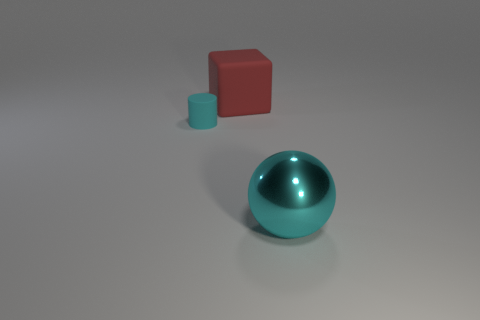What size is the metallic thing that is the same color as the small cylinder?
Ensure brevity in your answer.  Large. Does the large object that is in front of the block have the same material as the big red object?
Offer a very short reply. No. Is there another cylinder of the same color as the small cylinder?
Offer a very short reply. No. Does the cyan object that is behind the large shiny ball have the same shape as the cyan thing that is in front of the tiny cyan rubber cylinder?
Offer a terse response. No. Are there any things made of the same material as the ball?
Give a very brief answer. No. What number of cyan things are tiny rubber objects or matte cubes?
Offer a very short reply. 1. How big is the object that is right of the cyan cylinder and in front of the red block?
Offer a terse response. Large. Is the number of small cyan matte cylinders that are to the left of the tiny cyan cylinder greater than the number of cyan balls?
Make the answer very short. No. What number of balls are green things or large cyan metallic things?
Your response must be concise. 1. There is a thing that is both right of the tiny rubber cylinder and behind the big cyan shiny object; what shape is it?
Offer a terse response. Cube. 